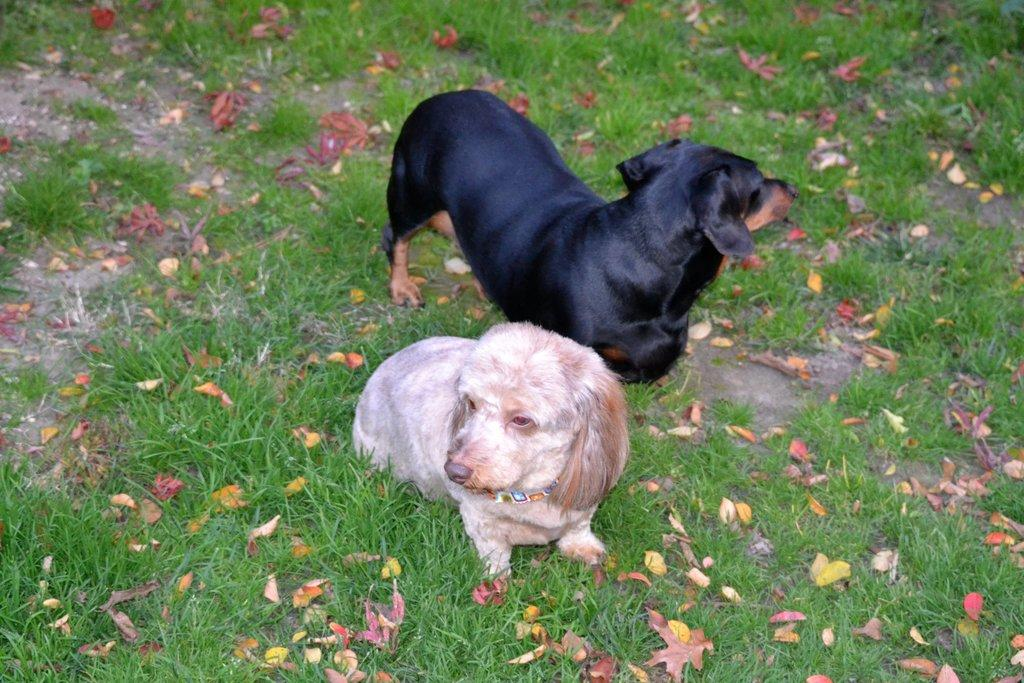How many dogs are in the image? There are two dogs in the image. What colors do the dogs have? The dogs have brown, white, and black colors. What type of vegetation is present on the ground in the image? There is green grass on the ground in the image. What type of natural debris can be seen on the ground? Dry leaves are visible in the image. What type of store can be seen in the background of the image? There is no store present in the image; it features two dogs and natural elements like grass and leaves. 